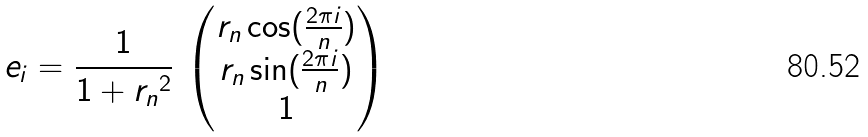<formula> <loc_0><loc_0><loc_500><loc_500>e _ { i } = \frac { 1 } { 1 + { r _ { n } } ^ { 2 } } \, \begin{pmatrix} r _ { n } \cos ( \frac { 2 \pi i } { n } ) \\ r _ { n } \sin ( \frac { 2 \pi i } { n } ) \\ 1 \end{pmatrix}</formula> 